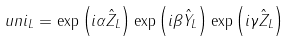<formula> <loc_0><loc_0><loc_500><loc_500>\ u n i _ { L } = \exp \left ( i \alpha \hat { Z } _ { L } \right ) \exp \left ( i \beta \hat { Y } _ { L } \right ) \exp \left ( i \gamma \hat { Z } _ { L } \right )</formula> 